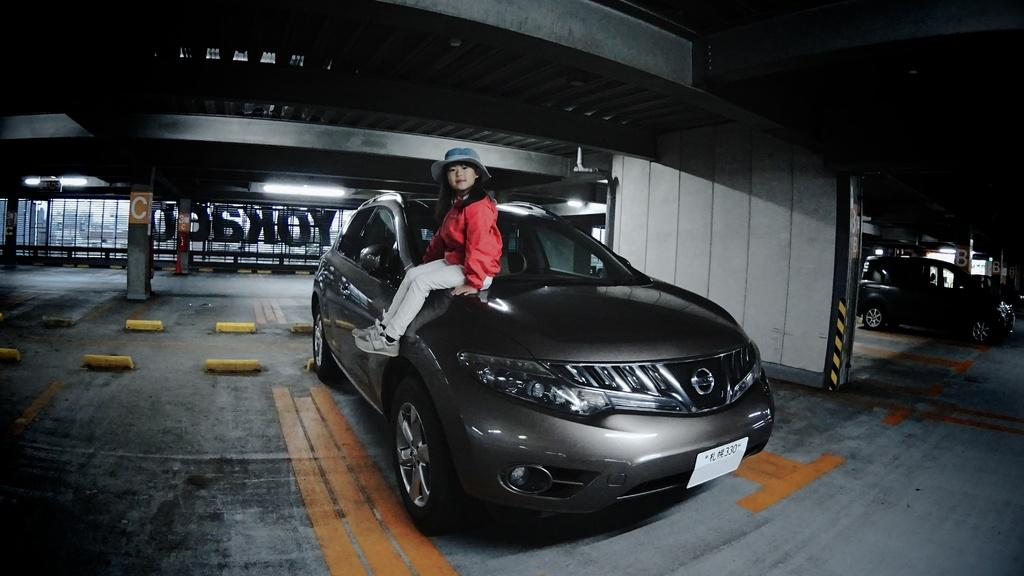What is the girl doing in the image? The girl is sitting on a car in the image. What else can be seen on the surface in the image? There are other cars on the surface in the image. What architectural features are present in the image? There are pillars in the image. What type of surface is visible in the image? There is a rooftop in the image. What is written or displayed on a glass wall in the image? There is text on a glass wall in the image. What type of music is the girl playing on the car in the image? There is no music or instrument visible in the image, so it cannot be determined what type of music the girl might be playing. 